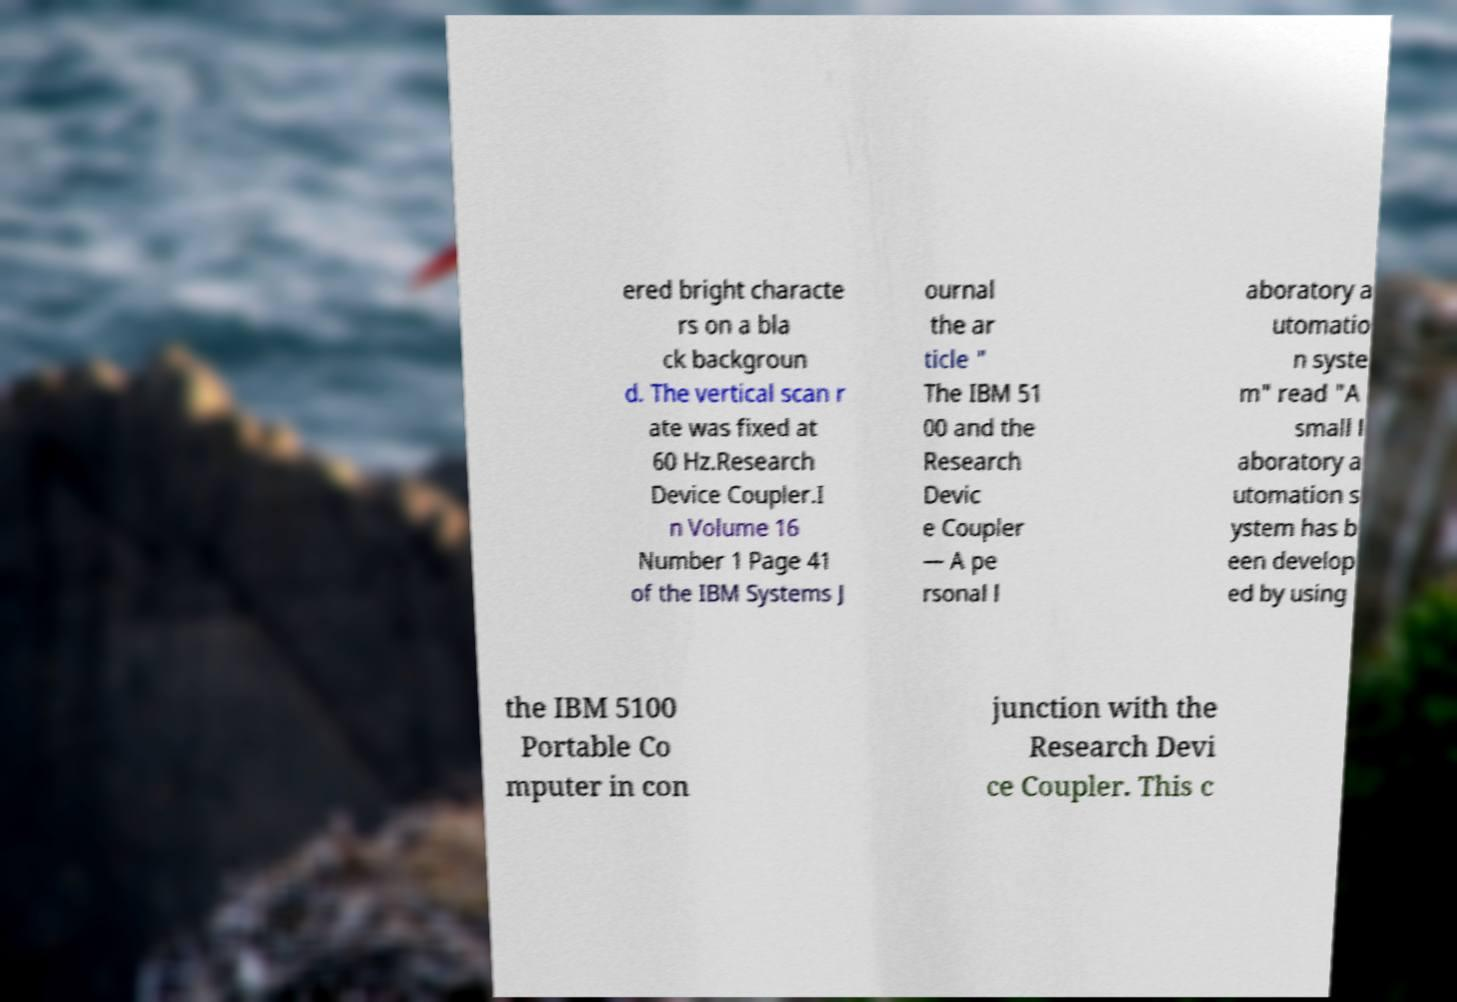There's text embedded in this image that I need extracted. Can you transcribe it verbatim? ered bright characte rs on a bla ck backgroun d. The vertical scan r ate was fixed at 60 Hz.Research Device Coupler.I n Volume 16 Number 1 Page 41 of the IBM Systems J ournal the ar ticle " The IBM 51 00 and the Research Devic e Coupler — A pe rsonal l aboratory a utomatio n syste m" read "A small l aboratory a utomation s ystem has b een develop ed by using the IBM 5100 Portable Co mputer in con junction with the Research Devi ce Coupler. This c 